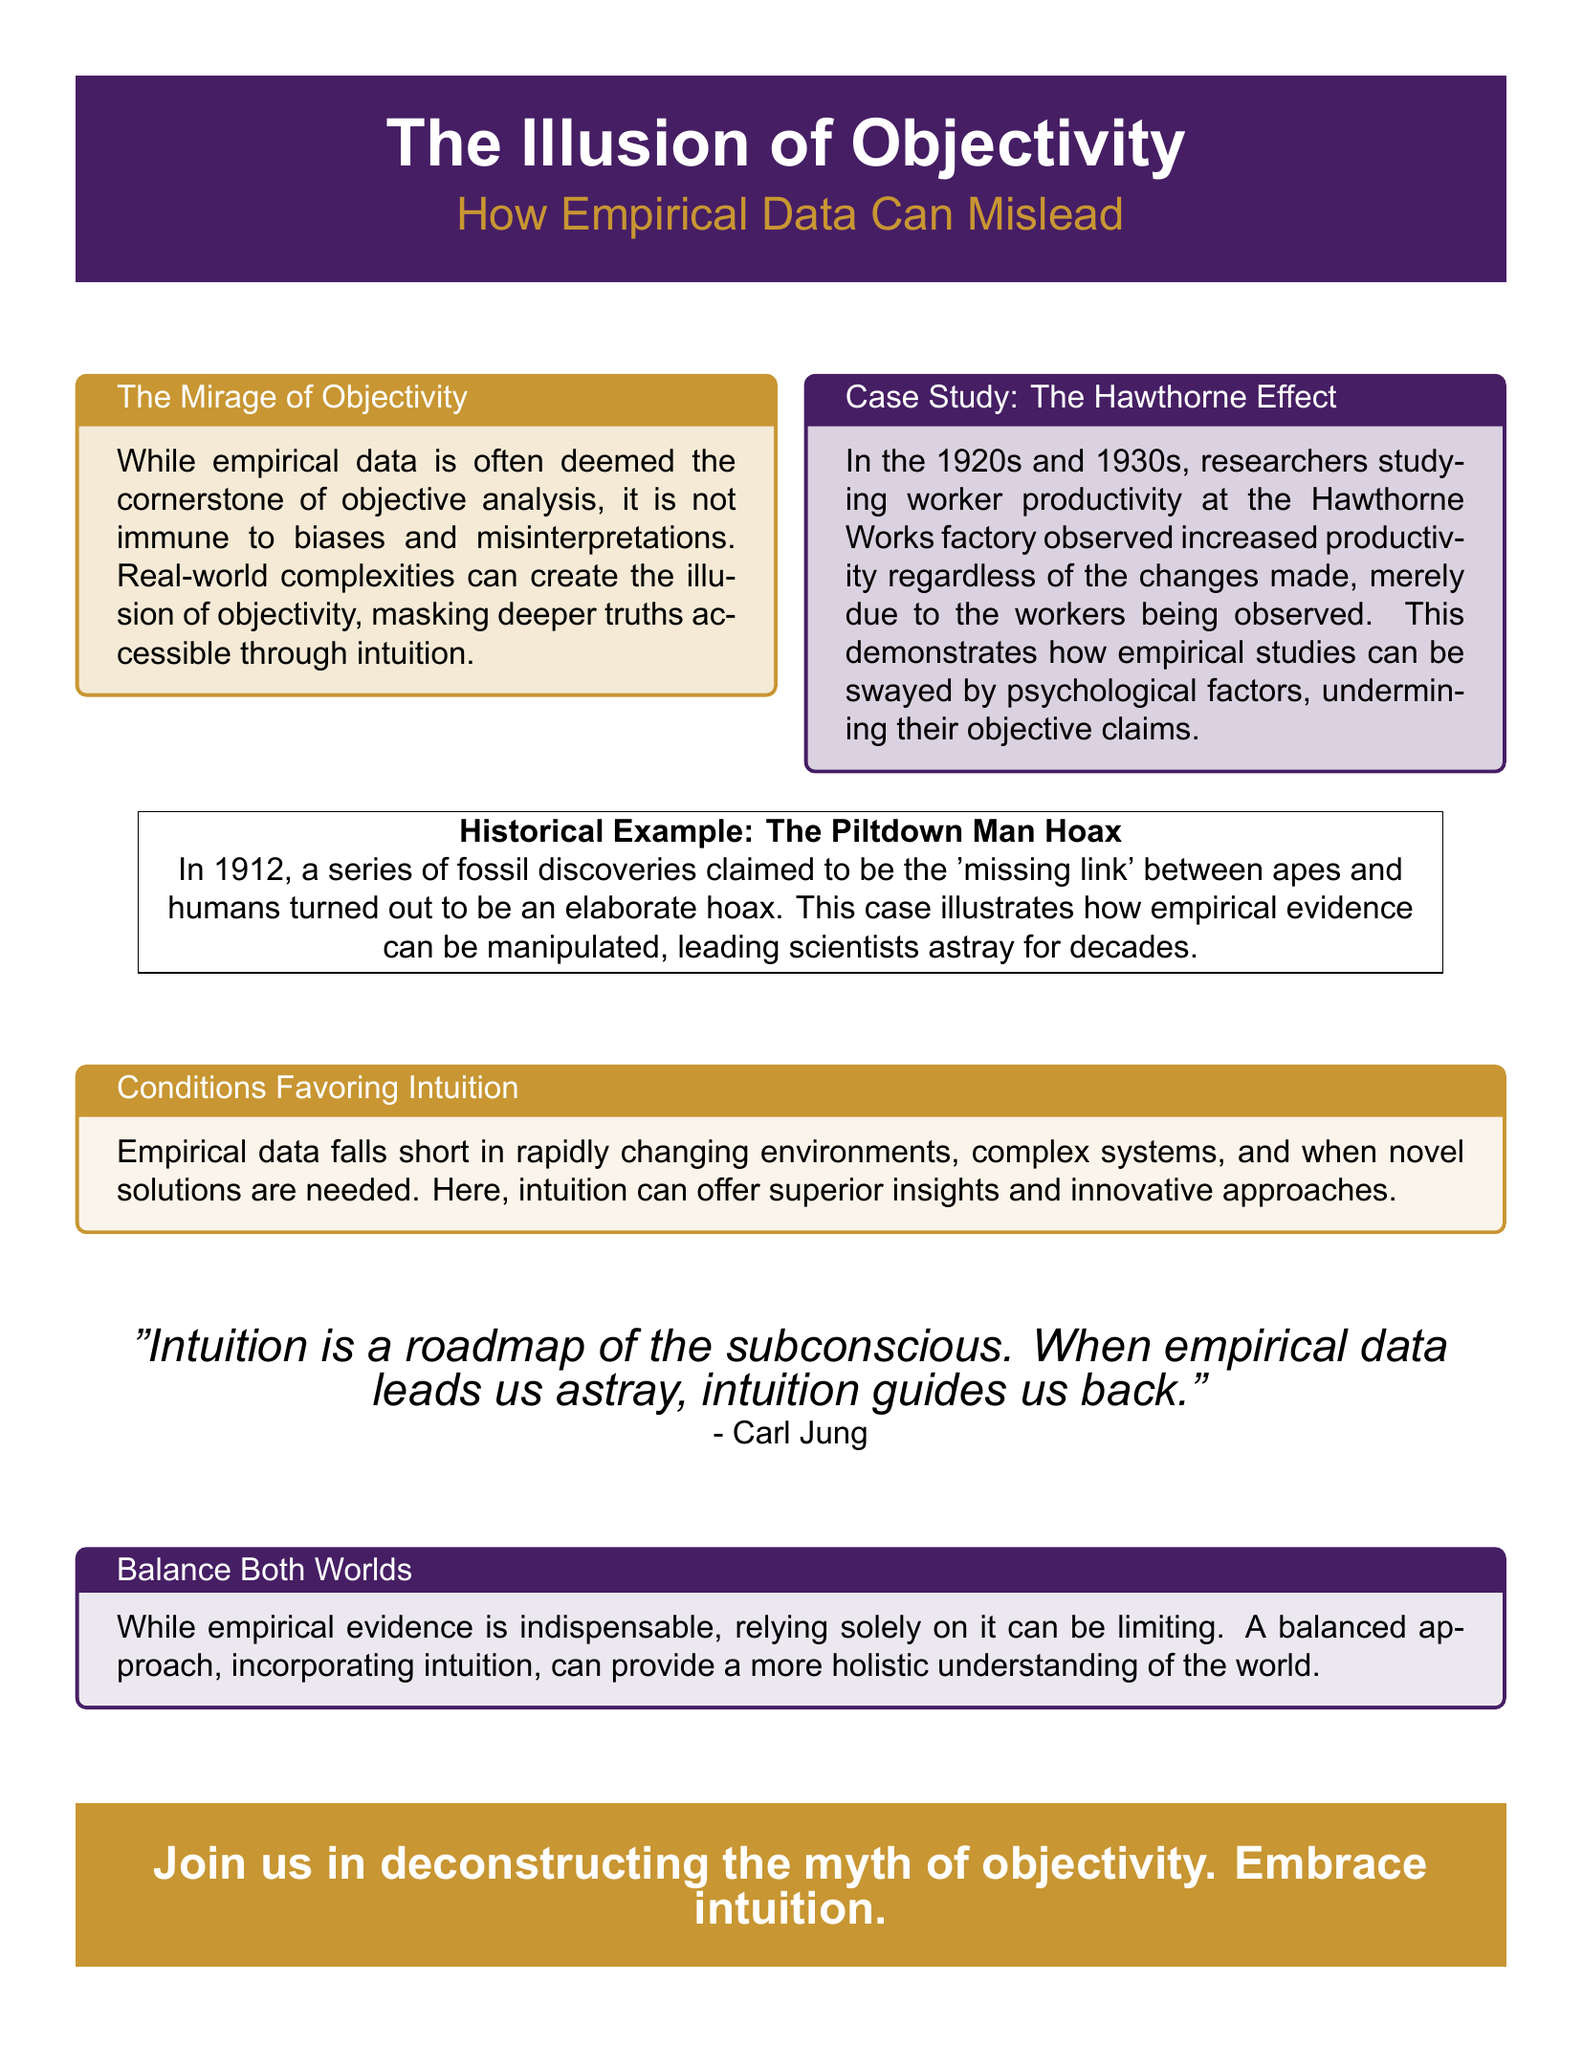What is the title of the flyer? The title is prominently displayed at the top of the document.
Answer: The Illusion of Objectivity What is the subtitle of the flyer? The subtitle further clarifies the focus of the document.
Answer: How Empirical Data Can Mislead What psychological effect is discussed in the case study? The case study highlights a specific phenomenon affecting productivity.
Answer: The Hawthorne Effect What year did the Piltdown Man discovery occur? The historical example provides a specific date for the hoax.
Answer: 1912 Who is quoted in the flyer? The document features a significant figure in psychology.
Answer: Carl Jung What metaphor does the flyer use to describe intuition? The flyer includes a phrase that encapsulates the nature of intuition.
Answer: A roadmap of the subconscious What is suggested as a necessary balance? The content advocates for a specific approach to understanding.
Answer: Both empirical evidence and intuition What can undermine the claims of empirical studies? The document discusses factors that can affect objective analysis.
Answer: Psychological factors 